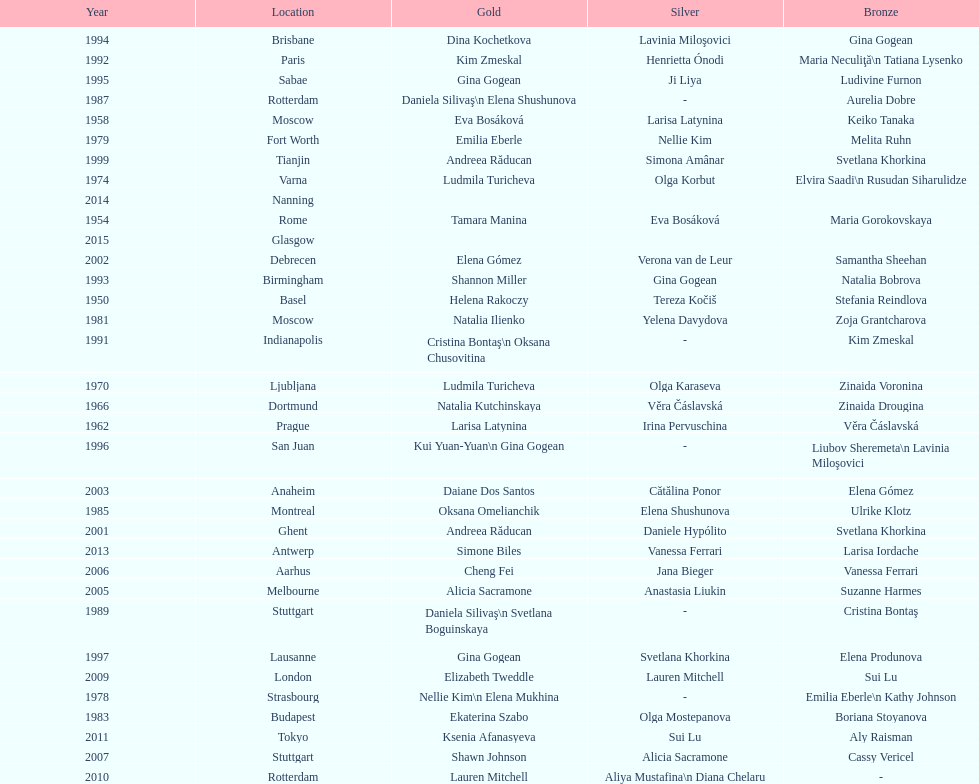As of 2013, what is the total number of floor exercise gold medals won by american women at the world championships? 5. 